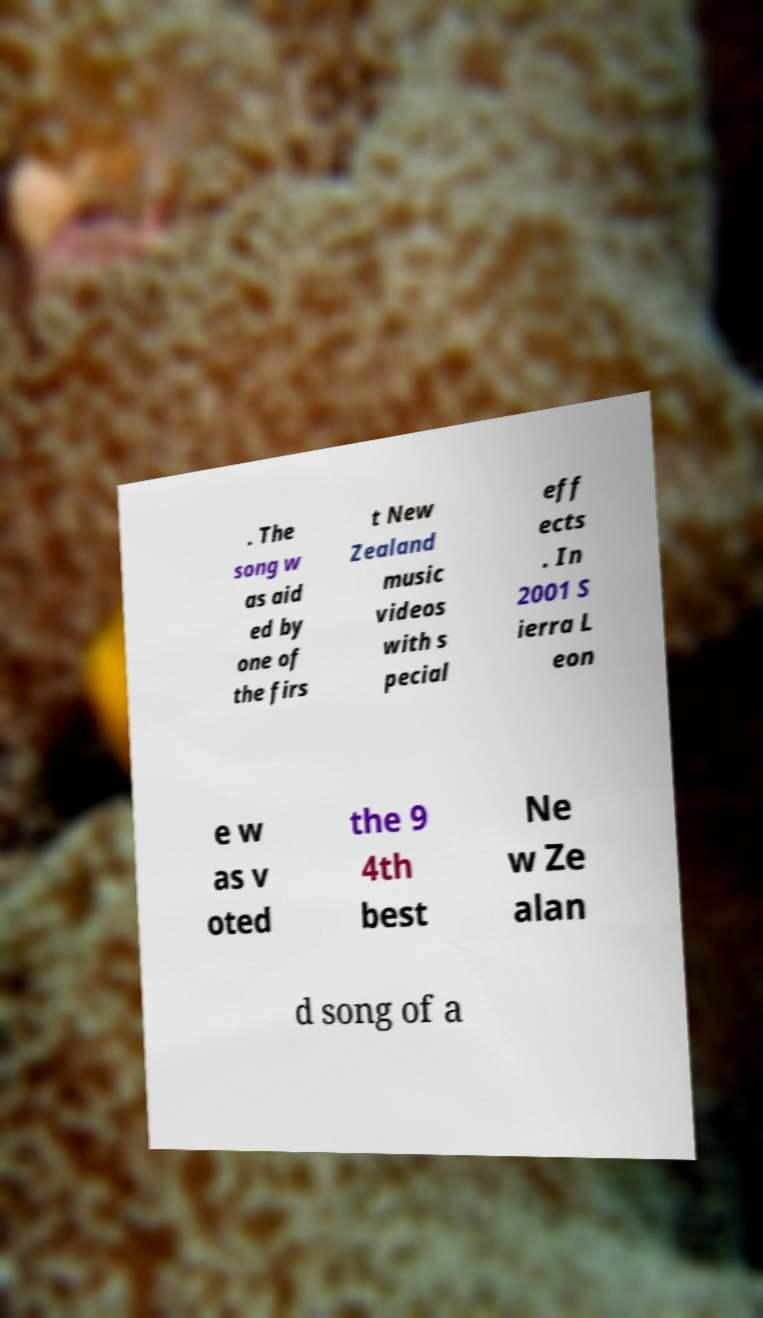Can you accurately transcribe the text from the provided image for me? . The song w as aid ed by one of the firs t New Zealand music videos with s pecial eff ects . In 2001 S ierra L eon e w as v oted the 9 4th best Ne w Ze alan d song of a 